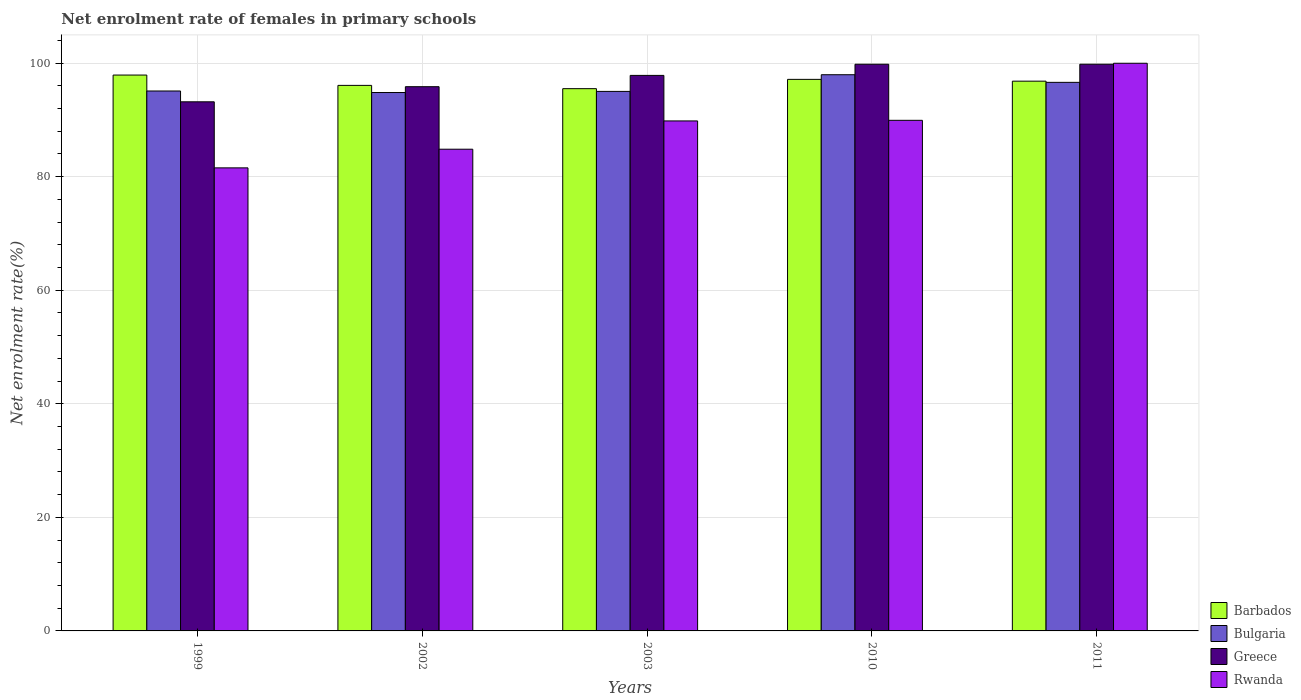How many different coloured bars are there?
Your answer should be compact. 4. How many groups of bars are there?
Ensure brevity in your answer.  5. Are the number of bars on each tick of the X-axis equal?
Your answer should be compact. Yes. How many bars are there on the 4th tick from the left?
Offer a very short reply. 4. How many bars are there on the 2nd tick from the right?
Provide a short and direct response. 4. In how many cases, is the number of bars for a given year not equal to the number of legend labels?
Provide a succinct answer. 0. What is the net enrolment rate of females in primary schools in Rwanda in 2011?
Provide a succinct answer. 99.98. Across all years, what is the maximum net enrolment rate of females in primary schools in Barbados?
Offer a terse response. 97.9. Across all years, what is the minimum net enrolment rate of females in primary schools in Barbados?
Provide a short and direct response. 95.51. What is the total net enrolment rate of females in primary schools in Greece in the graph?
Make the answer very short. 486.51. What is the difference between the net enrolment rate of females in primary schools in Barbados in 2010 and that in 2011?
Make the answer very short. 0.32. What is the difference between the net enrolment rate of females in primary schools in Greece in 2010 and the net enrolment rate of females in primary schools in Bulgaria in 1999?
Your answer should be very brief. 4.72. What is the average net enrolment rate of females in primary schools in Barbados per year?
Your response must be concise. 96.69. In the year 2003, what is the difference between the net enrolment rate of females in primary schools in Rwanda and net enrolment rate of females in primary schools in Bulgaria?
Provide a succinct answer. -5.2. What is the ratio of the net enrolment rate of females in primary schools in Rwanda in 1999 to that in 2011?
Your answer should be compact. 0.82. Is the difference between the net enrolment rate of females in primary schools in Rwanda in 1999 and 2003 greater than the difference between the net enrolment rate of females in primary schools in Bulgaria in 1999 and 2003?
Offer a terse response. No. What is the difference between the highest and the second highest net enrolment rate of females in primary schools in Bulgaria?
Offer a very short reply. 1.34. What is the difference between the highest and the lowest net enrolment rate of females in primary schools in Rwanda?
Provide a short and direct response. 18.42. Is it the case that in every year, the sum of the net enrolment rate of females in primary schools in Barbados and net enrolment rate of females in primary schools in Greece is greater than the sum of net enrolment rate of females in primary schools in Bulgaria and net enrolment rate of females in primary schools in Rwanda?
Your answer should be compact. Yes. What does the 2nd bar from the left in 2002 represents?
Give a very brief answer. Bulgaria. What does the 3rd bar from the right in 2011 represents?
Your answer should be compact. Bulgaria. How many years are there in the graph?
Offer a very short reply. 5. What is the difference between two consecutive major ticks on the Y-axis?
Offer a very short reply. 20. Does the graph contain any zero values?
Offer a very short reply. No. Does the graph contain grids?
Offer a very short reply. Yes. How are the legend labels stacked?
Provide a succinct answer. Vertical. What is the title of the graph?
Provide a short and direct response. Net enrolment rate of females in primary schools. What is the label or title of the Y-axis?
Provide a succinct answer. Net enrolment rate(%). What is the Net enrolment rate(%) in Barbados in 1999?
Keep it short and to the point. 97.9. What is the Net enrolment rate(%) of Bulgaria in 1999?
Provide a short and direct response. 95.1. What is the Net enrolment rate(%) of Greece in 1999?
Your answer should be very brief. 93.19. What is the Net enrolment rate(%) of Rwanda in 1999?
Ensure brevity in your answer.  81.56. What is the Net enrolment rate(%) of Barbados in 2002?
Your response must be concise. 96.08. What is the Net enrolment rate(%) of Bulgaria in 2002?
Your answer should be very brief. 94.83. What is the Net enrolment rate(%) of Greece in 2002?
Make the answer very short. 95.85. What is the Net enrolment rate(%) of Rwanda in 2002?
Your answer should be very brief. 84.84. What is the Net enrolment rate(%) in Barbados in 2003?
Your answer should be compact. 95.51. What is the Net enrolment rate(%) of Bulgaria in 2003?
Make the answer very short. 95.02. What is the Net enrolment rate(%) of Greece in 2003?
Keep it short and to the point. 97.84. What is the Net enrolment rate(%) of Rwanda in 2003?
Give a very brief answer. 89.82. What is the Net enrolment rate(%) in Barbados in 2010?
Your response must be concise. 97.14. What is the Net enrolment rate(%) of Bulgaria in 2010?
Provide a succinct answer. 97.96. What is the Net enrolment rate(%) of Greece in 2010?
Make the answer very short. 99.81. What is the Net enrolment rate(%) in Rwanda in 2010?
Provide a succinct answer. 89.93. What is the Net enrolment rate(%) of Barbados in 2011?
Give a very brief answer. 96.83. What is the Net enrolment rate(%) of Bulgaria in 2011?
Give a very brief answer. 96.62. What is the Net enrolment rate(%) in Greece in 2011?
Keep it short and to the point. 99.81. What is the Net enrolment rate(%) of Rwanda in 2011?
Offer a very short reply. 99.98. Across all years, what is the maximum Net enrolment rate(%) in Barbados?
Offer a terse response. 97.9. Across all years, what is the maximum Net enrolment rate(%) of Bulgaria?
Keep it short and to the point. 97.96. Across all years, what is the maximum Net enrolment rate(%) in Greece?
Your answer should be compact. 99.81. Across all years, what is the maximum Net enrolment rate(%) of Rwanda?
Provide a short and direct response. 99.98. Across all years, what is the minimum Net enrolment rate(%) of Barbados?
Provide a succinct answer. 95.51. Across all years, what is the minimum Net enrolment rate(%) of Bulgaria?
Your answer should be very brief. 94.83. Across all years, what is the minimum Net enrolment rate(%) of Greece?
Your answer should be compact. 93.19. Across all years, what is the minimum Net enrolment rate(%) of Rwanda?
Provide a short and direct response. 81.56. What is the total Net enrolment rate(%) of Barbados in the graph?
Provide a succinct answer. 483.46. What is the total Net enrolment rate(%) of Bulgaria in the graph?
Give a very brief answer. 479.53. What is the total Net enrolment rate(%) of Greece in the graph?
Your answer should be very brief. 486.51. What is the total Net enrolment rate(%) in Rwanda in the graph?
Your answer should be compact. 446.13. What is the difference between the Net enrolment rate(%) in Barbados in 1999 and that in 2002?
Provide a short and direct response. 1.82. What is the difference between the Net enrolment rate(%) of Bulgaria in 1999 and that in 2002?
Offer a very short reply. 0.27. What is the difference between the Net enrolment rate(%) of Greece in 1999 and that in 2002?
Offer a terse response. -2.66. What is the difference between the Net enrolment rate(%) in Rwanda in 1999 and that in 2002?
Make the answer very short. -3.28. What is the difference between the Net enrolment rate(%) in Barbados in 1999 and that in 2003?
Your response must be concise. 2.4. What is the difference between the Net enrolment rate(%) in Bulgaria in 1999 and that in 2003?
Offer a very short reply. 0.07. What is the difference between the Net enrolment rate(%) of Greece in 1999 and that in 2003?
Provide a succinct answer. -4.65. What is the difference between the Net enrolment rate(%) in Rwanda in 1999 and that in 2003?
Make the answer very short. -8.27. What is the difference between the Net enrolment rate(%) of Barbados in 1999 and that in 2010?
Offer a terse response. 0.76. What is the difference between the Net enrolment rate(%) in Bulgaria in 1999 and that in 2010?
Provide a short and direct response. -2.87. What is the difference between the Net enrolment rate(%) in Greece in 1999 and that in 2010?
Offer a very short reply. -6.62. What is the difference between the Net enrolment rate(%) of Rwanda in 1999 and that in 2010?
Make the answer very short. -8.37. What is the difference between the Net enrolment rate(%) of Barbados in 1999 and that in 2011?
Make the answer very short. 1.08. What is the difference between the Net enrolment rate(%) in Bulgaria in 1999 and that in 2011?
Provide a succinct answer. -1.52. What is the difference between the Net enrolment rate(%) in Greece in 1999 and that in 2011?
Ensure brevity in your answer.  -6.62. What is the difference between the Net enrolment rate(%) in Rwanda in 1999 and that in 2011?
Provide a succinct answer. -18.42. What is the difference between the Net enrolment rate(%) in Barbados in 2002 and that in 2003?
Keep it short and to the point. 0.58. What is the difference between the Net enrolment rate(%) in Bulgaria in 2002 and that in 2003?
Provide a short and direct response. -0.2. What is the difference between the Net enrolment rate(%) in Greece in 2002 and that in 2003?
Your answer should be very brief. -1.99. What is the difference between the Net enrolment rate(%) of Rwanda in 2002 and that in 2003?
Ensure brevity in your answer.  -4.98. What is the difference between the Net enrolment rate(%) in Barbados in 2002 and that in 2010?
Offer a very short reply. -1.06. What is the difference between the Net enrolment rate(%) in Bulgaria in 2002 and that in 2010?
Provide a succinct answer. -3.14. What is the difference between the Net enrolment rate(%) in Greece in 2002 and that in 2010?
Offer a very short reply. -3.96. What is the difference between the Net enrolment rate(%) of Rwanda in 2002 and that in 2010?
Your answer should be very brief. -5.09. What is the difference between the Net enrolment rate(%) of Barbados in 2002 and that in 2011?
Give a very brief answer. -0.74. What is the difference between the Net enrolment rate(%) in Bulgaria in 2002 and that in 2011?
Your answer should be very brief. -1.79. What is the difference between the Net enrolment rate(%) of Greece in 2002 and that in 2011?
Provide a succinct answer. -3.96. What is the difference between the Net enrolment rate(%) of Rwanda in 2002 and that in 2011?
Your response must be concise. -15.14. What is the difference between the Net enrolment rate(%) in Barbados in 2003 and that in 2010?
Your answer should be very brief. -1.64. What is the difference between the Net enrolment rate(%) in Bulgaria in 2003 and that in 2010?
Offer a very short reply. -2.94. What is the difference between the Net enrolment rate(%) of Greece in 2003 and that in 2010?
Provide a succinct answer. -1.97. What is the difference between the Net enrolment rate(%) of Rwanda in 2003 and that in 2010?
Keep it short and to the point. -0.11. What is the difference between the Net enrolment rate(%) of Barbados in 2003 and that in 2011?
Make the answer very short. -1.32. What is the difference between the Net enrolment rate(%) in Bulgaria in 2003 and that in 2011?
Your answer should be very brief. -1.59. What is the difference between the Net enrolment rate(%) in Greece in 2003 and that in 2011?
Ensure brevity in your answer.  -1.97. What is the difference between the Net enrolment rate(%) of Rwanda in 2003 and that in 2011?
Ensure brevity in your answer.  -10.16. What is the difference between the Net enrolment rate(%) of Barbados in 2010 and that in 2011?
Provide a succinct answer. 0.32. What is the difference between the Net enrolment rate(%) of Bulgaria in 2010 and that in 2011?
Provide a short and direct response. 1.34. What is the difference between the Net enrolment rate(%) of Greece in 2010 and that in 2011?
Your response must be concise. -0. What is the difference between the Net enrolment rate(%) in Rwanda in 2010 and that in 2011?
Make the answer very short. -10.05. What is the difference between the Net enrolment rate(%) of Barbados in 1999 and the Net enrolment rate(%) of Bulgaria in 2002?
Your response must be concise. 3.08. What is the difference between the Net enrolment rate(%) in Barbados in 1999 and the Net enrolment rate(%) in Greece in 2002?
Offer a very short reply. 2.05. What is the difference between the Net enrolment rate(%) in Barbados in 1999 and the Net enrolment rate(%) in Rwanda in 2002?
Offer a terse response. 13.06. What is the difference between the Net enrolment rate(%) in Bulgaria in 1999 and the Net enrolment rate(%) in Greece in 2002?
Your answer should be very brief. -0.76. What is the difference between the Net enrolment rate(%) of Bulgaria in 1999 and the Net enrolment rate(%) of Rwanda in 2002?
Your answer should be very brief. 10.25. What is the difference between the Net enrolment rate(%) in Greece in 1999 and the Net enrolment rate(%) in Rwanda in 2002?
Provide a succinct answer. 8.35. What is the difference between the Net enrolment rate(%) of Barbados in 1999 and the Net enrolment rate(%) of Bulgaria in 2003?
Offer a very short reply. 2.88. What is the difference between the Net enrolment rate(%) of Barbados in 1999 and the Net enrolment rate(%) of Greece in 2003?
Offer a terse response. 0.06. What is the difference between the Net enrolment rate(%) of Barbados in 1999 and the Net enrolment rate(%) of Rwanda in 2003?
Ensure brevity in your answer.  8.08. What is the difference between the Net enrolment rate(%) in Bulgaria in 1999 and the Net enrolment rate(%) in Greece in 2003?
Your response must be concise. -2.75. What is the difference between the Net enrolment rate(%) of Bulgaria in 1999 and the Net enrolment rate(%) of Rwanda in 2003?
Keep it short and to the point. 5.27. What is the difference between the Net enrolment rate(%) in Greece in 1999 and the Net enrolment rate(%) in Rwanda in 2003?
Ensure brevity in your answer.  3.37. What is the difference between the Net enrolment rate(%) in Barbados in 1999 and the Net enrolment rate(%) in Bulgaria in 2010?
Your answer should be compact. -0.06. What is the difference between the Net enrolment rate(%) of Barbados in 1999 and the Net enrolment rate(%) of Greece in 2010?
Your answer should be very brief. -1.91. What is the difference between the Net enrolment rate(%) in Barbados in 1999 and the Net enrolment rate(%) in Rwanda in 2010?
Offer a terse response. 7.97. What is the difference between the Net enrolment rate(%) in Bulgaria in 1999 and the Net enrolment rate(%) in Greece in 2010?
Your response must be concise. -4.71. What is the difference between the Net enrolment rate(%) in Bulgaria in 1999 and the Net enrolment rate(%) in Rwanda in 2010?
Provide a short and direct response. 5.17. What is the difference between the Net enrolment rate(%) in Greece in 1999 and the Net enrolment rate(%) in Rwanda in 2010?
Keep it short and to the point. 3.26. What is the difference between the Net enrolment rate(%) in Barbados in 1999 and the Net enrolment rate(%) in Bulgaria in 2011?
Offer a terse response. 1.28. What is the difference between the Net enrolment rate(%) of Barbados in 1999 and the Net enrolment rate(%) of Greece in 2011?
Make the answer very short. -1.91. What is the difference between the Net enrolment rate(%) of Barbados in 1999 and the Net enrolment rate(%) of Rwanda in 2011?
Provide a short and direct response. -2.08. What is the difference between the Net enrolment rate(%) of Bulgaria in 1999 and the Net enrolment rate(%) of Greece in 2011?
Keep it short and to the point. -4.72. What is the difference between the Net enrolment rate(%) in Bulgaria in 1999 and the Net enrolment rate(%) in Rwanda in 2011?
Offer a very short reply. -4.89. What is the difference between the Net enrolment rate(%) of Greece in 1999 and the Net enrolment rate(%) of Rwanda in 2011?
Keep it short and to the point. -6.79. What is the difference between the Net enrolment rate(%) of Barbados in 2002 and the Net enrolment rate(%) of Bulgaria in 2003?
Offer a terse response. 1.06. What is the difference between the Net enrolment rate(%) in Barbados in 2002 and the Net enrolment rate(%) in Greece in 2003?
Your response must be concise. -1.76. What is the difference between the Net enrolment rate(%) in Barbados in 2002 and the Net enrolment rate(%) in Rwanda in 2003?
Your response must be concise. 6.26. What is the difference between the Net enrolment rate(%) in Bulgaria in 2002 and the Net enrolment rate(%) in Greece in 2003?
Keep it short and to the point. -3.02. What is the difference between the Net enrolment rate(%) in Bulgaria in 2002 and the Net enrolment rate(%) in Rwanda in 2003?
Your response must be concise. 5. What is the difference between the Net enrolment rate(%) in Greece in 2002 and the Net enrolment rate(%) in Rwanda in 2003?
Your response must be concise. 6.03. What is the difference between the Net enrolment rate(%) in Barbados in 2002 and the Net enrolment rate(%) in Bulgaria in 2010?
Offer a terse response. -1.88. What is the difference between the Net enrolment rate(%) in Barbados in 2002 and the Net enrolment rate(%) in Greece in 2010?
Your response must be concise. -3.73. What is the difference between the Net enrolment rate(%) in Barbados in 2002 and the Net enrolment rate(%) in Rwanda in 2010?
Make the answer very short. 6.16. What is the difference between the Net enrolment rate(%) of Bulgaria in 2002 and the Net enrolment rate(%) of Greece in 2010?
Provide a succinct answer. -4.98. What is the difference between the Net enrolment rate(%) in Bulgaria in 2002 and the Net enrolment rate(%) in Rwanda in 2010?
Your answer should be very brief. 4.9. What is the difference between the Net enrolment rate(%) of Greece in 2002 and the Net enrolment rate(%) of Rwanda in 2010?
Provide a short and direct response. 5.92. What is the difference between the Net enrolment rate(%) in Barbados in 2002 and the Net enrolment rate(%) in Bulgaria in 2011?
Make the answer very short. -0.53. What is the difference between the Net enrolment rate(%) in Barbados in 2002 and the Net enrolment rate(%) in Greece in 2011?
Your answer should be compact. -3.73. What is the difference between the Net enrolment rate(%) in Barbados in 2002 and the Net enrolment rate(%) in Rwanda in 2011?
Keep it short and to the point. -3.9. What is the difference between the Net enrolment rate(%) of Bulgaria in 2002 and the Net enrolment rate(%) of Greece in 2011?
Provide a succinct answer. -4.99. What is the difference between the Net enrolment rate(%) of Bulgaria in 2002 and the Net enrolment rate(%) of Rwanda in 2011?
Your answer should be compact. -5.15. What is the difference between the Net enrolment rate(%) in Greece in 2002 and the Net enrolment rate(%) in Rwanda in 2011?
Provide a short and direct response. -4.13. What is the difference between the Net enrolment rate(%) of Barbados in 2003 and the Net enrolment rate(%) of Bulgaria in 2010?
Ensure brevity in your answer.  -2.46. What is the difference between the Net enrolment rate(%) in Barbados in 2003 and the Net enrolment rate(%) in Greece in 2010?
Provide a succinct answer. -4.3. What is the difference between the Net enrolment rate(%) of Barbados in 2003 and the Net enrolment rate(%) of Rwanda in 2010?
Your response must be concise. 5.58. What is the difference between the Net enrolment rate(%) in Bulgaria in 2003 and the Net enrolment rate(%) in Greece in 2010?
Provide a short and direct response. -4.79. What is the difference between the Net enrolment rate(%) of Bulgaria in 2003 and the Net enrolment rate(%) of Rwanda in 2010?
Offer a terse response. 5.1. What is the difference between the Net enrolment rate(%) of Greece in 2003 and the Net enrolment rate(%) of Rwanda in 2010?
Ensure brevity in your answer.  7.91. What is the difference between the Net enrolment rate(%) of Barbados in 2003 and the Net enrolment rate(%) of Bulgaria in 2011?
Provide a short and direct response. -1.11. What is the difference between the Net enrolment rate(%) in Barbados in 2003 and the Net enrolment rate(%) in Greece in 2011?
Your answer should be very brief. -4.31. What is the difference between the Net enrolment rate(%) in Barbados in 2003 and the Net enrolment rate(%) in Rwanda in 2011?
Make the answer very short. -4.48. What is the difference between the Net enrolment rate(%) in Bulgaria in 2003 and the Net enrolment rate(%) in Greece in 2011?
Provide a short and direct response. -4.79. What is the difference between the Net enrolment rate(%) in Bulgaria in 2003 and the Net enrolment rate(%) in Rwanda in 2011?
Offer a very short reply. -4.96. What is the difference between the Net enrolment rate(%) of Greece in 2003 and the Net enrolment rate(%) of Rwanda in 2011?
Give a very brief answer. -2.14. What is the difference between the Net enrolment rate(%) in Barbados in 2010 and the Net enrolment rate(%) in Bulgaria in 2011?
Provide a short and direct response. 0.53. What is the difference between the Net enrolment rate(%) of Barbados in 2010 and the Net enrolment rate(%) of Greece in 2011?
Ensure brevity in your answer.  -2.67. What is the difference between the Net enrolment rate(%) of Barbados in 2010 and the Net enrolment rate(%) of Rwanda in 2011?
Keep it short and to the point. -2.84. What is the difference between the Net enrolment rate(%) of Bulgaria in 2010 and the Net enrolment rate(%) of Greece in 2011?
Ensure brevity in your answer.  -1.85. What is the difference between the Net enrolment rate(%) of Bulgaria in 2010 and the Net enrolment rate(%) of Rwanda in 2011?
Offer a terse response. -2.02. What is the difference between the Net enrolment rate(%) in Greece in 2010 and the Net enrolment rate(%) in Rwanda in 2011?
Keep it short and to the point. -0.17. What is the average Net enrolment rate(%) in Barbados per year?
Provide a succinct answer. 96.69. What is the average Net enrolment rate(%) of Bulgaria per year?
Provide a short and direct response. 95.91. What is the average Net enrolment rate(%) of Greece per year?
Provide a short and direct response. 97.3. What is the average Net enrolment rate(%) in Rwanda per year?
Provide a succinct answer. 89.23. In the year 1999, what is the difference between the Net enrolment rate(%) in Barbados and Net enrolment rate(%) in Bulgaria?
Your response must be concise. 2.81. In the year 1999, what is the difference between the Net enrolment rate(%) in Barbados and Net enrolment rate(%) in Greece?
Your response must be concise. 4.71. In the year 1999, what is the difference between the Net enrolment rate(%) in Barbados and Net enrolment rate(%) in Rwanda?
Your answer should be very brief. 16.34. In the year 1999, what is the difference between the Net enrolment rate(%) in Bulgaria and Net enrolment rate(%) in Greece?
Make the answer very short. 1.9. In the year 1999, what is the difference between the Net enrolment rate(%) in Bulgaria and Net enrolment rate(%) in Rwanda?
Offer a very short reply. 13.54. In the year 1999, what is the difference between the Net enrolment rate(%) in Greece and Net enrolment rate(%) in Rwanda?
Give a very brief answer. 11.63. In the year 2002, what is the difference between the Net enrolment rate(%) of Barbados and Net enrolment rate(%) of Bulgaria?
Your response must be concise. 1.26. In the year 2002, what is the difference between the Net enrolment rate(%) in Barbados and Net enrolment rate(%) in Greece?
Provide a succinct answer. 0.23. In the year 2002, what is the difference between the Net enrolment rate(%) in Barbados and Net enrolment rate(%) in Rwanda?
Your answer should be compact. 11.24. In the year 2002, what is the difference between the Net enrolment rate(%) of Bulgaria and Net enrolment rate(%) of Greece?
Your answer should be compact. -1.03. In the year 2002, what is the difference between the Net enrolment rate(%) in Bulgaria and Net enrolment rate(%) in Rwanda?
Your answer should be compact. 9.98. In the year 2002, what is the difference between the Net enrolment rate(%) of Greece and Net enrolment rate(%) of Rwanda?
Your answer should be compact. 11.01. In the year 2003, what is the difference between the Net enrolment rate(%) in Barbados and Net enrolment rate(%) in Bulgaria?
Give a very brief answer. 0.48. In the year 2003, what is the difference between the Net enrolment rate(%) of Barbados and Net enrolment rate(%) of Greece?
Make the answer very short. -2.34. In the year 2003, what is the difference between the Net enrolment rate(%) of Barbados and Net enrolment rate(%) of Rwanda?
Your response must be concise. 5.68. In the year 2003, what is the difference between the Net enrolment rate(%) in Bulgaria and Net enrolment rate(%) in Greece?
Your response must be concise. -2.82. In the year 2003, what is the difference between the Net enrolment rate(%) in Bulgaria and Net enrolment rate(%) in Rwanda?
Provide a succinct answer. 5.2. In the year 2003, what is the difference between the Net enrolment rate(%) in Greece and Net enrolment rate(%) in Rwanda?
Provide a succinct answer. 8.02. In the year 2010, what is the difference between the Net enrolment rate(%) in Barbados and Net enrolment rate(%) in Bulgaria?
Make the answer very short. -0.82. In the year 2010, what is the difference between the Net enrolment rate(%) of Barbados and Net enrolment rate(%) of Greece?
Your answer should be very brief. -2.67. In the year 2010, what is the difference between the Net enrolment rate(%) of Barbados and Net enrolment rate(%) of Rwanda?
Give a very brief answer. 7.22. In the year 2010, what is the difference between the Net enrolment rate(%) in Bulgaria and Net enrolment rate(%) in Greece?
Your response must be concise. -1.85. In the year 2010, what is the difference between the Net enrolment rate(%) in Bulgaria and Net enrolment rate(%) in Rwanda?
Provide a succinct answer. 8.03. In the year 2010, what is the difference between the Net enrolment rate(%) in Greece and Net enrolment rate(%) in Rwanda?
Provide a short and direct response. 9.88. In the year 2011, what is the difference between the Net enrolment rate(%) in Barbados and Net enrolment rate(%) in Bulgaria?
Ensure brevity in your answer.  0.21. In the year 2011, what is the difference between the Net enrolment rate(%) in Barbados and Net enrolment rate(%) in Greece?
Your answer should be compact. -2.99. In the year 2011, what is the difference between the Net enrolment rate(%) of Barbados and Net enrolment rate(%) of Rwanda?
Ensure brevity in your answer.  -3.15. In the year 2011, what is the difference between the Net enrolment rate(%) in Bulgaria and Net enrolment rate(%) in Greece?
Offer a very short reply. -3.2. In the year 2011, what is the difference between the Net enrolment rate(%) in Bulgaria and Net enrolment rate(%) in Rwanda?
Make the answer very short. -3.36. In the year 2011, what is the difference between the Net enrolment rate(%) in Greece and Net enrolment rate(%) in Rwanda?
Provide a short and direct response. -0.17. What is the ratio of the Net enrolment rate(%) in Barbados in 1999 to that in 2002?
Your response must be concise. 1.02. What is the ratio of the Net enrolment rate(%) of Greece in 1999 to that in 2002?
Provide a short and direct response. 0.97. What is the ratio of the Net enrolment rate(%) of Rwanda in 1999 to that in 2002?
Ensure brevity in your answer.  0.96. What is the ratio of the Net enrolment rate(%) in Barbados in 1999 to that in 2003?
Offer a terse response. 1.03. What is the ratio of the Net enrolment rate(%) in Bulgaria in 1999 to that in 2003?
Keep it short and to the point. 1. What is the ratio of the Net enrolment rate(%) in Greece in 1999 to that in 2003?
Offer a terse response. 0.95. What is the ratio of the Net enrolment rate(%) in Rwanda in 1999 to that in 2003?
Your answer should be very brief. 0.91. What is the ratio of the Net enrolment rate(%) of Bulgaria in 1999 to that in 2010?
Offer a very short reply. 0.97. What is the ratio of the Net enrolment rate(%) of Greece in 1999 to that in 2010?
Make the answer very short. 0.93. What is the ratio of the Net enrolment rate(%) of Rwanda in 1999 to that in 2010?
Give a very brief answer. 0.91. What is the ratio of the Net enrolment rate(%) in Barbados in 1999 to that in 2011?
Offer a very short reply. 1.01. What is the ratio of the Net enrolment rate(%) in Bulgaria in 1999 to that in 2011?
Keep it short and to the point. 0.98. What is the ratio of the Net enrolment rate(%) of Greece in 1999 to that in 2011?
Give a very brief answer. 0.93. What is the ratio of the Net enrolment rate(%) in Rwanda in 1999 to that in 2011?
Your answer should be very brief. 0.82. What is the ratio of the Net enrolment rate(%) of Bulgaria in 2002 to that in 2003?
Your answer should be compact. 1. What is the ratio of the Net enrolment rate(%) in Greece in 2002 to that in 2003?
Ensure brevity in your answer.  0.98. What is the ratio of the Net enrolment rate(%) in Rwanda in 2002 to that in 2003?
Ensure brevity in your answer.  0.94. What is the ratio of the Net enrolment rate(%) in Greece in 2002 to that in 2010?
Make the answer very short. 0.96. What is the ratio of the Net enrolment rate(%) in Rwanda in 2002 to that in 2010?
Your answer should be compact. 0.94. What is the ratio of the Net enrolment rate(%) of Barbados in 2002 to that in 2011?
Make the answer very short. 0.99. What is the ratio of the Net enrolment rate(%) in Bulgaria in 2002 to that in 2011?
Make the answer very short. 0.98. What is the ratio of the Net enrolment rate(%) of Greece in 2002 to that in 2011?
Provide a short and direct response. 0.96. What is the ratio of the Net enrolment rate(%) of Rwanda in 2002 to that in 2011?
Your answer should be very brief. 0.85. What is the ratio of the Net enrolment rate(%) of Barbados in 2003 to that in 2010?
Provide a short and direct response. 0.98. What is the ratio of the Net enrolment rate(%) of Bulgaria in 2003 to that in 2010?
Ensure brevity in your answer.  0.97. What is the ratio of the Net enrolment rate(%) in Greece in 2003 to that in 2010?
Provide a succinct answer. 0.98. What is the ratio of the Net enrolment rate(%) of Barbados in 2003 to that in 2011?
Give a very brief answer. 0.99. What is the ratio of the Net enrolment rate(%) of Bulgaria in 2003 to that in 2011?
Your answer should be very brief. 0.98. What is the ratio of the Net enrolment rate(%) in Greece in 2003 to that in 2011?
Make the answer very short. 0.98. What is the ratio of the Net enrolment rate(%) of Rwanda in 2003 to that in 2011?
Your answer should be compact. 0.9. What is the ratio of the Net enrolment rate(%) of Barbados in 2010 to that in 2011?
Keep it short and to the point. 1. What is the ratio of the Net enrolment rate(%) in Bulgaria in 2010 to that in 2011?
Your response must be concise. 1.01. What is the ratio of the Net enrolment rate(%) in Rwanda in 2010 to that in 2011?
Provide a succinct answer. 0.9. What is the difference between the highest and the second highest Net enrolment rate(%) in Barbados?
Make the answer very short. 0.76. What is the difference between the highest and the second highest Net enrolment rate(%) in Bulgaria?
Ensure brevity in your answer.  1.34. What is the difference between the highest and the second highest Net enrolment rate(%) of Greece?
Make the answer very short. 0. What is the difference between the highest and the second highest Net enrolment rate(%) in Rwanda?
Your answer should be very brief. 10.05. What is the difference between the highest and the lowest Net enrolment rate(%) in Barbados?
Your answer should be very brief. 2.4. What is the difference between the highest and the lowest Net enrolment rate(%) in Bulgaria?
Ensure brevity in your answer.  3.14. What is the difference between the highest and the lowest Net enrolment rate(%) of Greece?
Ensure brevity in your answer.  6.62. What is the difference between the highest and the lowest Net enrolment rate(%) in Rwanda?
Your answer should be very brief. 18.42. 